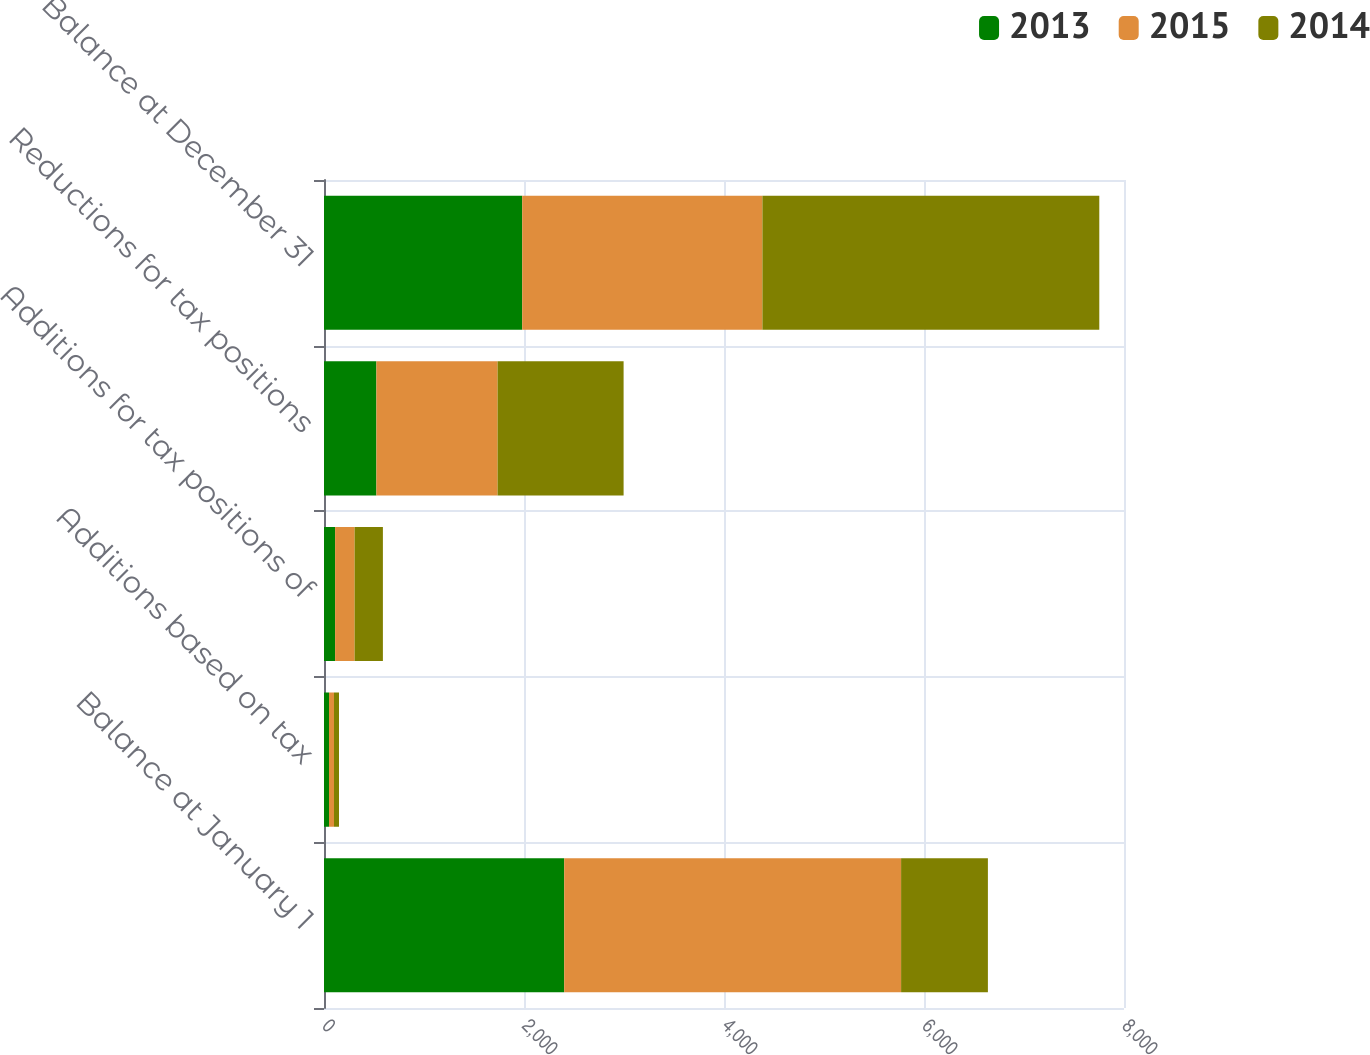Convert chart to OTSL. <chart><loc_0><loc_0><loc_500><loc_500><stacked_bar_chart><ecel><fcel>Balance at January 1<fcel>Additions based on tax<fcel>Additions for tax positions of<fcel>Reductions for tax positions<fcel>Balance at December 31<nl><fcel>2013<fcel>2402<fcel>50<fcel>111<fcel>524<fcel>1982<nl><fcel>2015<fcel>3369<fcel>50<fcel>195<fcel>1212<fcel>2402<nl><fcel>2014<fcel>868<fcel>50<fcel>283<fcel>1260<fcel>3369<nl></chart> 